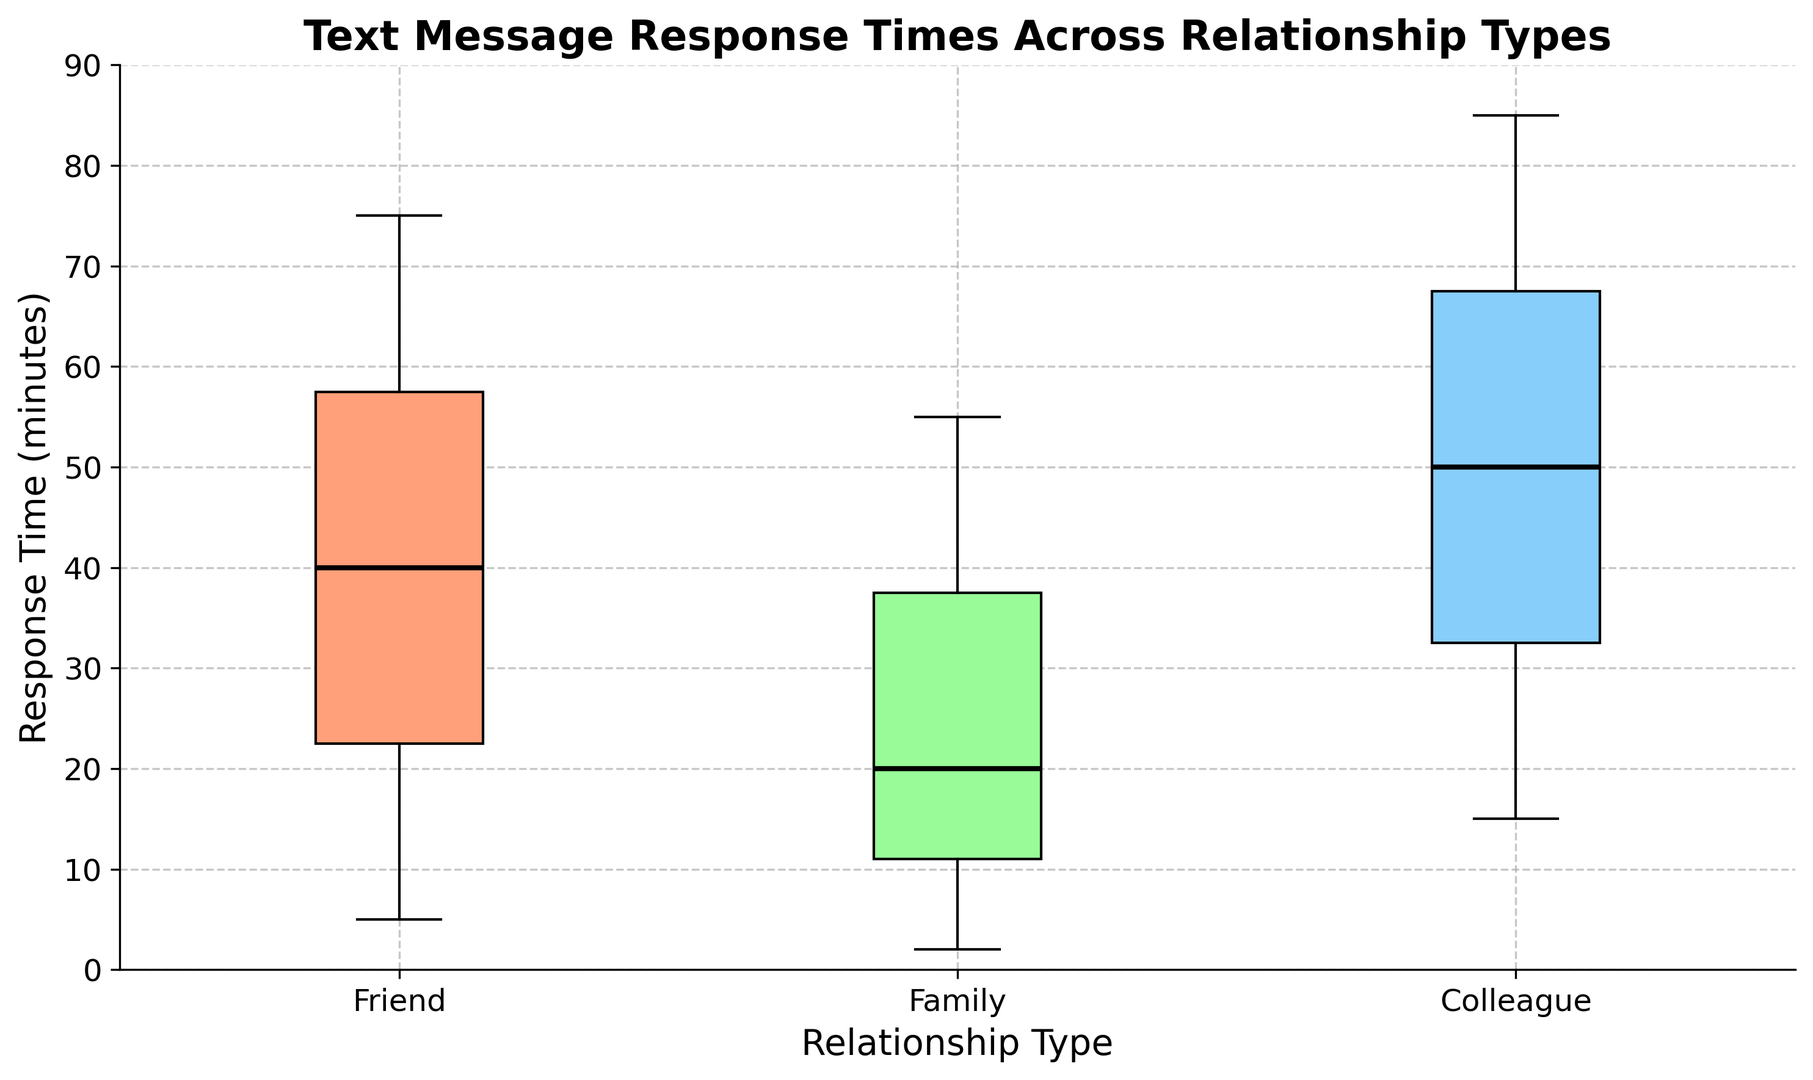What is the median response time for each relationship type? To find the median response times, look at the central line in each box for friends, family, and colleagues.
Answer: Friends: 37.5, Family: 20, Colleagues: 50 Which relationship type has the most variability in text message response times? Variability can be assessed by looking at the height of the boxes; the largest box indicates the most variability.
Answer: Friends How do the interquartile ranges (IQR) compare among the relationship types? The IQR is the height of the box (the difference between the upper and lower quartiles). Compare the height of the boxes for each group.
Answer: Friends > Colleagues > Family Which relationship type has the shortest median response time? Identify the middle line of each box plot and pick the lowest value.
Answer: Family Are there any outliers in the data, and if so, in which relationship types do they appear? Outliers are indicated by the red markers outside the whiskers. Check for any red markers.
Answer: Friends and Colleagues What is the range of response times for family members? The range is the difference between the maximum and minimum values in the whiskers for the family box plot.
Answer: 2 - 55 How do the 75th percentiles (upper quartiles) compare across relationship types? The 75th percentile is the top edge of each box. Compare the values.
Answer: Friends: 62.5, Family: 35, Colleagues: 70 Which relationship type has the highest median response time? Look at the middle lines in each box plot and identify the highest value.
Answer: Colleagues How does the color coding differ for each relationship type in the box plot? Identify the colors used for each box plot. Friends are salmon-colored, family is light green, and colleagues are light blue.
Answer: Friends: salmon, Family: light green, Colleagues: light blue What is the maximum response time observed for the "Friends" category? The maximum response time is the top whisker value for the friends box plot.
Answer: 75 